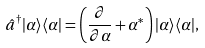<formula> <loc_0><loc_0><loc_500><loc_500>\hat { a } ^ { \dagger } | \alpha \rangle \langle \alpha | = \left ( \frac { \partial } { \partial \alpha } + \alpha ^ { * } \right ) | \alpha \rangle \langle \alpha | ,</formula> 